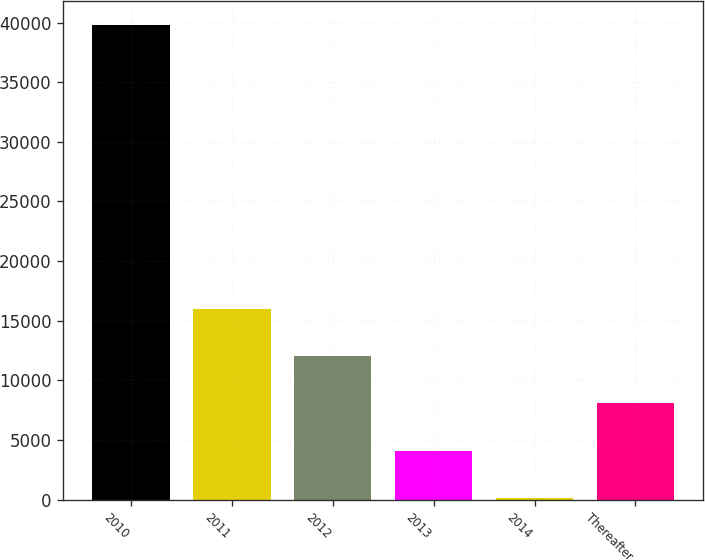Convert chart. <chart><loc_0><loc_0><loc_500><loc_500><bar_chart><fcel>2010<fcel>2011<fcel>2012<fcel>2013<fcel>2014<fcel>Thereafter<nl><fcel>39801<fcel>16003.8<fcel>12037.6<fcel>4105.2<fcel>139<fcel>8071.4<nl></chart> 